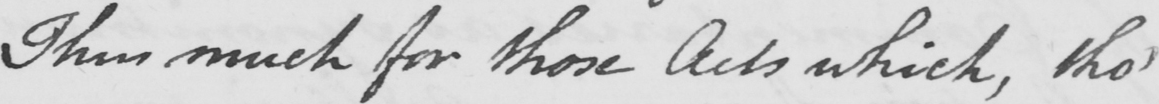What is written in this line of handwriting? This much for those Acts , which tho ' 